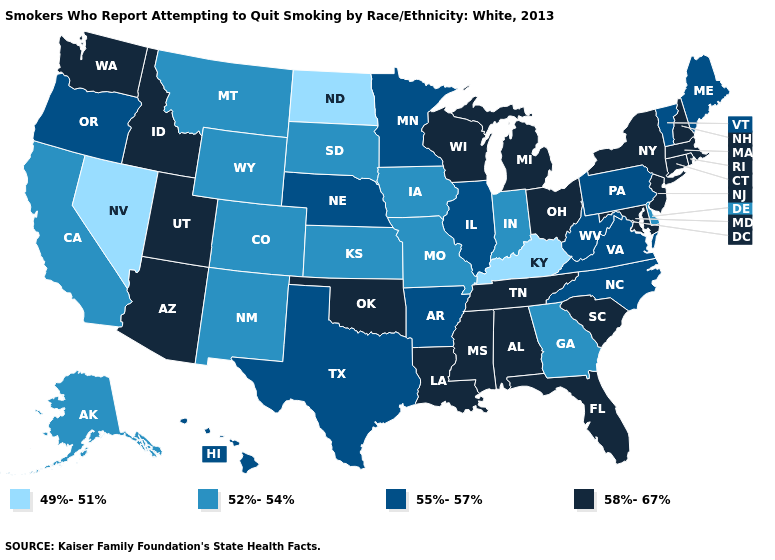Among the states that border Louisiana , which have the highest value?
Be succinct. Mississippi. Name the states that have a value in the range 55%-57%?
Concise answer only. Arkansas, Hawaii, Illinois, Maine, Minnesota, Nebraska, North Carolina, Oregon, Pennsylvania, Texas, Vermont, Virginia, West Virginia. Does Arkansas have the same value as Pennsylvania?
Give a very brief answer. Yes. Name the states that have a value in the range 49%-51%?
Keep it brief. Kentucky, Nevada, North Dakota. Is the legend a continuous bar?
Keep it brief. No. What is the value of Missouri?
Write a very short answer. 52%-54%. What is the lowest value in states that border New York?
Give a very brief answer. 55%-57%. Which states have the lowest value in the USA?
Concise answer only. Kentucky, Nevada, North Dakota. Does the first symbol in the legend represent the smallest category?
Keep it brief. Yes. Name the states that have a value in the range 58%-67%?
Answer briefly. Alabama, Arizona, Connecticut, Florida, Idaho, Louisiana, Maryland, Massachusetts, Michigan, Mississippi, New Hampshire, New Jersey, New York, Ohio, Oklahoma, Rhode Island, South Carolina, Tennessee, Utah, Washington, Wisconsin. What is the value of New Hampshire?
Answer briefly. 58%-67%. Name the states that have a value in the range 49%-51%?
Short answer required. Kentucky, Nevada, North Dakota. Name the states that have a value in the range 49%-51%?
Write a very short answer. Kentucky, Nevada, North Dakota. Among the states that border Mississippi , which have the lowest value?
Keep it brief. Arkansas. Name the states that have a value in the range 52%-54%?
Answer briefly. Alaska, California, Colorado, Delaware, Georgia, Indiana, Iowa, Kansas, Missouri, Montana, New Mexico, South Dakota, Wyoming. 